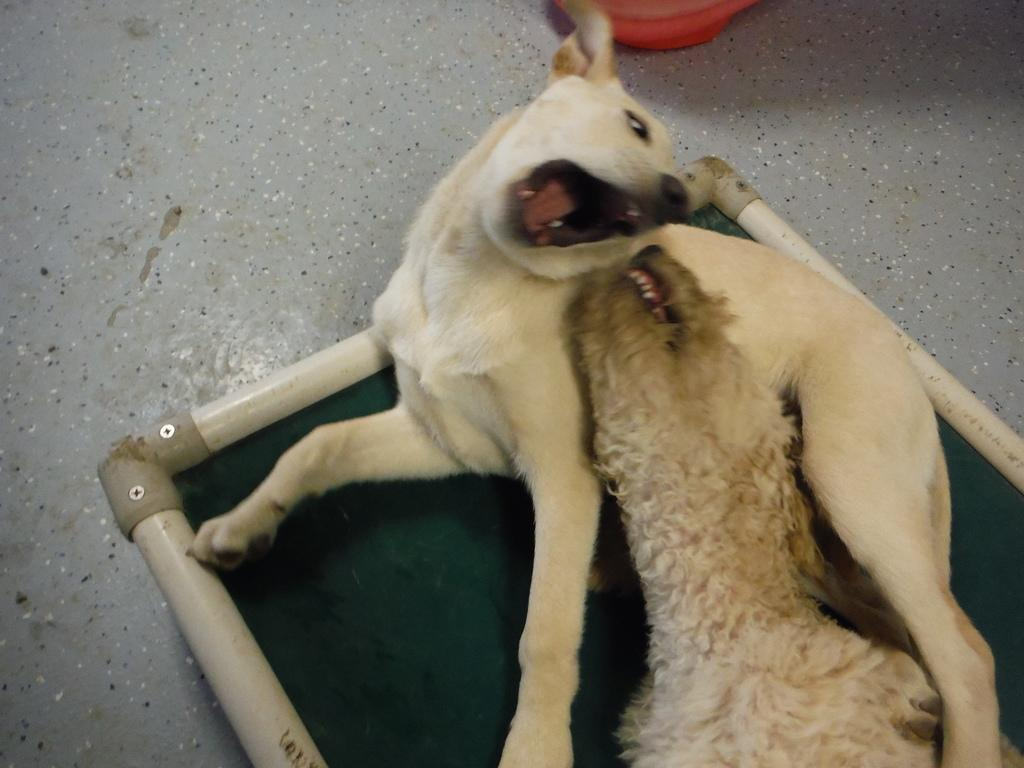What type of animal is in the image? There is a dog in the image. What is the dog doing in the image? The dog has its mouth open. Can you describe the other animal beside the dog? Unfortunately, the facts provided do not give any information about the other animal. What type of pickle is the dog holding in the image? There is no pickle present in the image. 